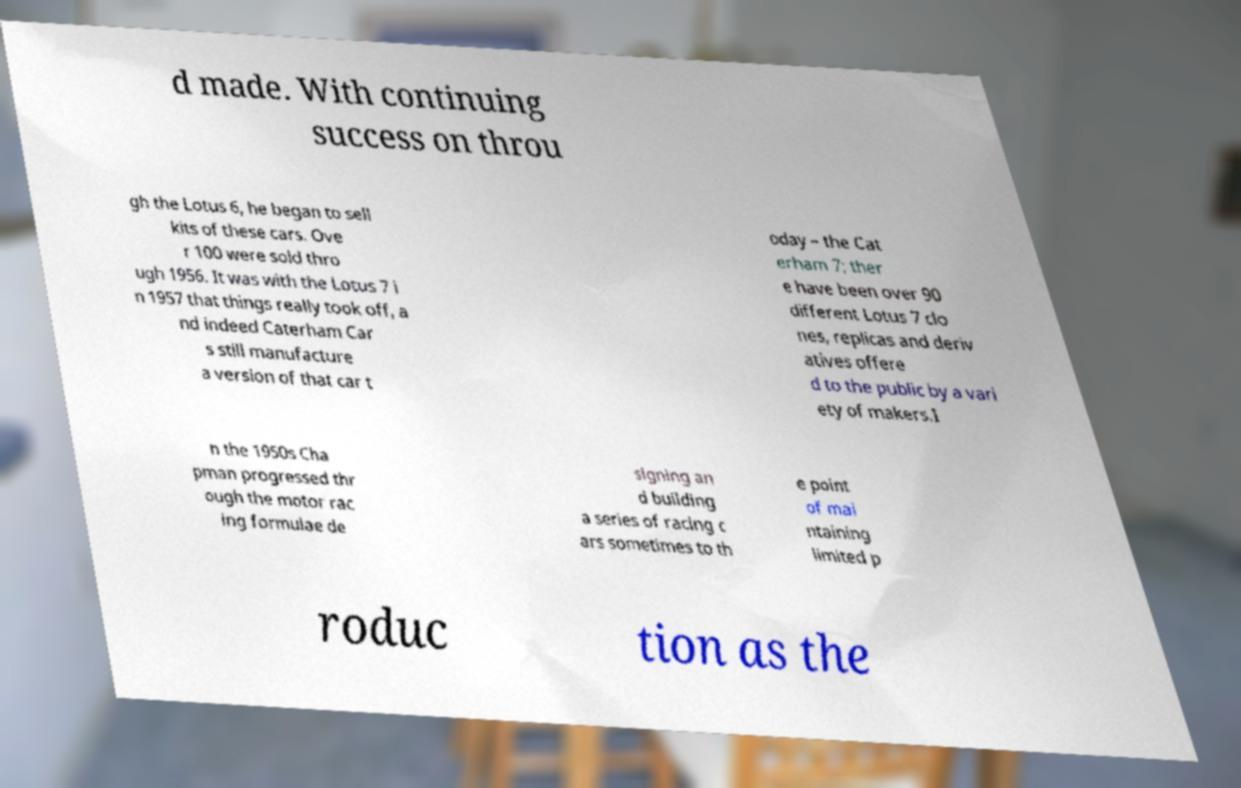I need the written content from this picture converted into text. Can you do that? d made. With continuing success on throu gh the Lotus 6, he began to sell kits of these cars. Ove r 100 were sold thro ugh 1956. It was with the Lotus 7 i n 1957 that things really took off, a nd indeed Caterham Car s still manufacture a version of that car t oday – the Cat erham 7; ther e have been over 90 different Lotus 7 clo nes, replicas and deriv atives offere d to the public by a vari ety of makers.I n the 1950s Cha pman progressed thr ough the motor rac ing formulae de signing an d building a series of racing c ars sometimes to th e point of mai ntaining limited p roduc tion as the 